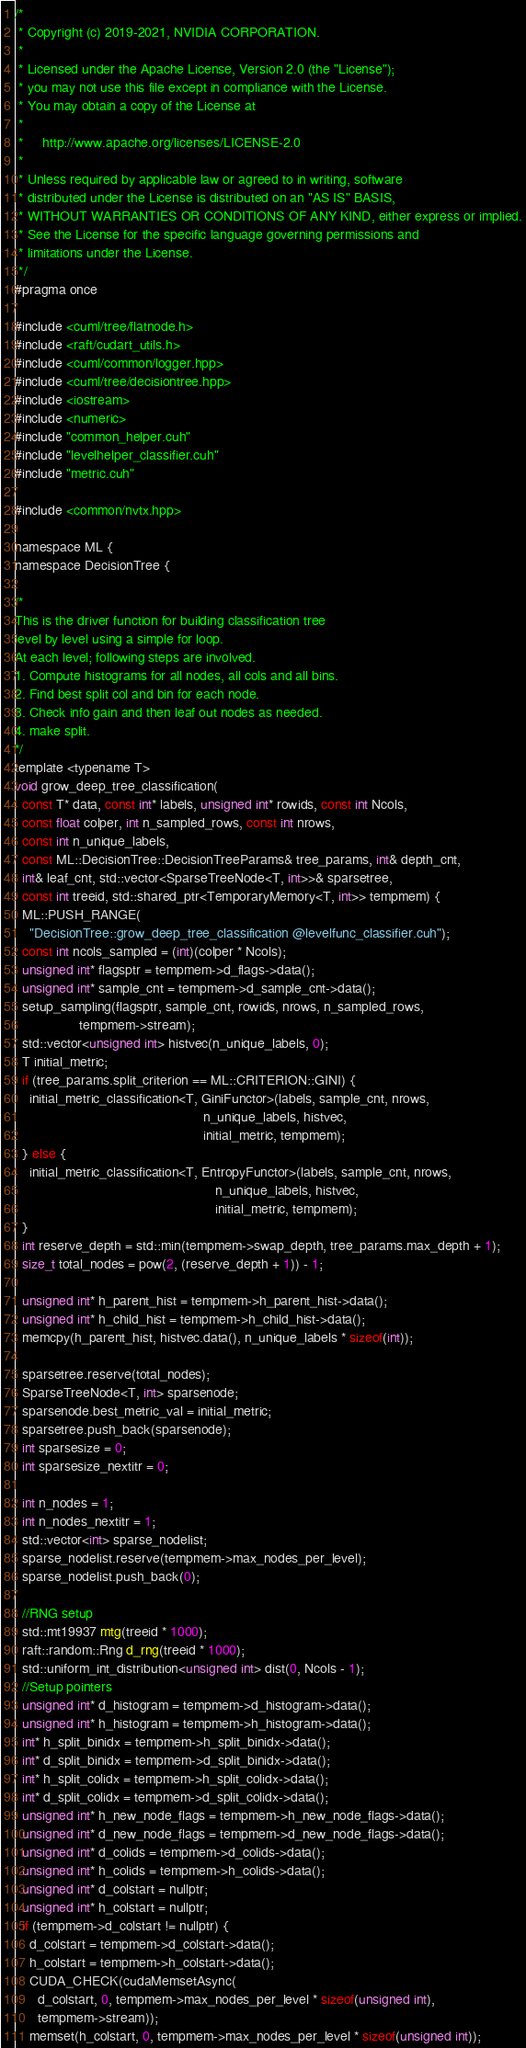<code> <loc_0><loc_0><loc_500><loc_500><_Cuda_>/*
 * Copyright (c) 2019-2021, NVIDIA CORPORATION.
 *
 * Licensed under the Apache License, Version 2.0 (the "License");
 * you may not use this file except in compliance with the License.
 * You may obtain a copy of the License at
 *
 *     http://www.apache.org/licenses/LICENSE-2.0
 *
 * Unless required by applicable law or agreed to in writing, software
 * distributed under the License is distributed on an "AS IS" BASIS,
 * WITHOUT WARRANTIES OR CONDITIONS OF ANY KIND, either express or implied.
 * See the License for the specific language governing permissions and
 * limitations under the License.
 */
#pragma once

#include <cuml/tree/flatnode.h>
#include <raft/cudart_utils.h>
#include <cuml/common/logger.hpp>
#include <cuml/tree/decisiontree.hpp>
#include <iostream>
#include <numeric>
#include "common_helper.cuh"
#include "levelhelper_classifier.cuh"
#include "metric.cuh"

#include <common/nvtx.hpp>

namespace ML {
namespace DecisionTree {

/*
This is the driver function for building classification tree
level by level using a simple for loop.
At each level; following steps are involved.
1. Compute histograms for all nodes, all cols and all bins.
2. Find best split col and bin for each node.
3. Check info gain and then leaf out nodes as needed.
4. make split.
*/
template <typename T>
void grow_deep_tree_classification(
  const T* data, const int* labels, unsigned int* rowids, const int Ncols,
  const float colper, int n_sampled_rows, const int nrows,
  const int n_unique_labels,
  const ML::DecisionTree::DecisionTreeParams& tree_params, int& depth_cnt,
  int& leaf_cnt, std::vector<SparseTreeNode<T, int>>& sparsetree,
  const int treeid, std::shared_ptr<TemporaryMemory<T, int>> tempmem) {
  ML::PUSH_RANGE(
    "DecisionTree::grow_deep_tree_classification @levelfunc_classifier.cuh");
  const int ncols_sampled = (int)(colper * Ncols);
  unsigned int* flagsptr = tempmem->d_flags->data();
  unsigned int* sample_cnt = tempmem->d_sample_cnt->data();
  setup_sampling(flagsptr, sample_cnt, rowids, nrows, n_sampled_rows,
                 tempmem->stream);
  std::vector<unsigned int> histvec(n_unique_labels, 0);
  T initial_metric;
  if (tree_params.split_criterion == ML::CRITERION::GINI) {
    initial_metric_classification<T, GiniFunctor>(labels, sample_cnt, nrows,
                                                  n_unique_labels, histvec,
                                                  initial_metric, tempmem);
  } else {
    initial_metric_classification<T, EntropyFunctor>(labels, sample_cnt, nrows,
                                                     n_unique_labels, histvec,
                                                     initial_metric, tempmem);
  }
  int reserve_depth = std::min(tempmem->swap_depth, tree_params.max_depth + 1);
  size_t total_nodes = pow(2, (reserve_depth + 1)) - 1;

  unsigned int* h_parent_hist = tempmem->h_parent_hist->data();
  unsigned int* h_child_hist = tempmem->h_child_hist->data();
  memcpy(h_parent_hist, histvec.data(), n_unique_labels * sizeof(int));

  sparsetree.reserve(total_nodes);
  SparseTreeNode<T, int> sparsenode;
  sparsenode.best_metric_val = initial_metric;
  sparsetree.push_back(sparsenode);
  int sparsesize = 0;
  int sparsesize_nextitr = 0;

  int n_nodes = 1;
  int n_nodes_nextitr = 1;
  std::vector<int> sparse_nodelist;
  sparse_nodelist.reserve(tempmem->max_nodes_per_level);
  sparse_nodelist.push_back(0);

  //RNG setup
  std::mt19937 mtg(treeid * 1000);
  raft::random::Rng d_rng(treeid * 1000);
  std::uniform_int_distribution<unsigned int> dist(0, Ncols - 1);
  //Setup pointers
  unsigned int* d_histogram = tempmem->d_histogram->data();
  unsigned int* h_histogram = tempmem->h_histogram->data();
  int* h_split_binidx = tempmem->h_split_binidx->data();
  int* d_split_binidx = tempmem->d_split_binidx->data();
  int* h_split_colidx = tempmem->h_split_colidx->data();
  int* d_split_colidx = tempmem->d_split_colidx->data();
  unsigned int* h_new_node_flags = tempmem->h_new_node_flags->data();
  unsigned int* d_new_node_flags = tempmem->d_new_node_flags->data();
  unsigned int* d_colids = tempmem->d_colids->data();
  unsigned int* h_colids = tempmem->h_colids->data();
  unsigned int* d_colstart = nullptr;
  unsigned int* h_colstart = nullptr;
  if (tempmem->d_colstart != nullptr) {
    d_colstart = tempmem->d_colstart->data();
    h_colstart = tempmem->h_colstart->data();
    CUDA_CHECK(cudaMemsetAsync(
      d_colstart, 0, tempmem->max_nodes_per_level * sizeof(unsigned int),
      tempmem->stream));
    memset(h_colstart, 0, tempmem->max_nodes_per_level * sizeof(unsigned int));</code> 